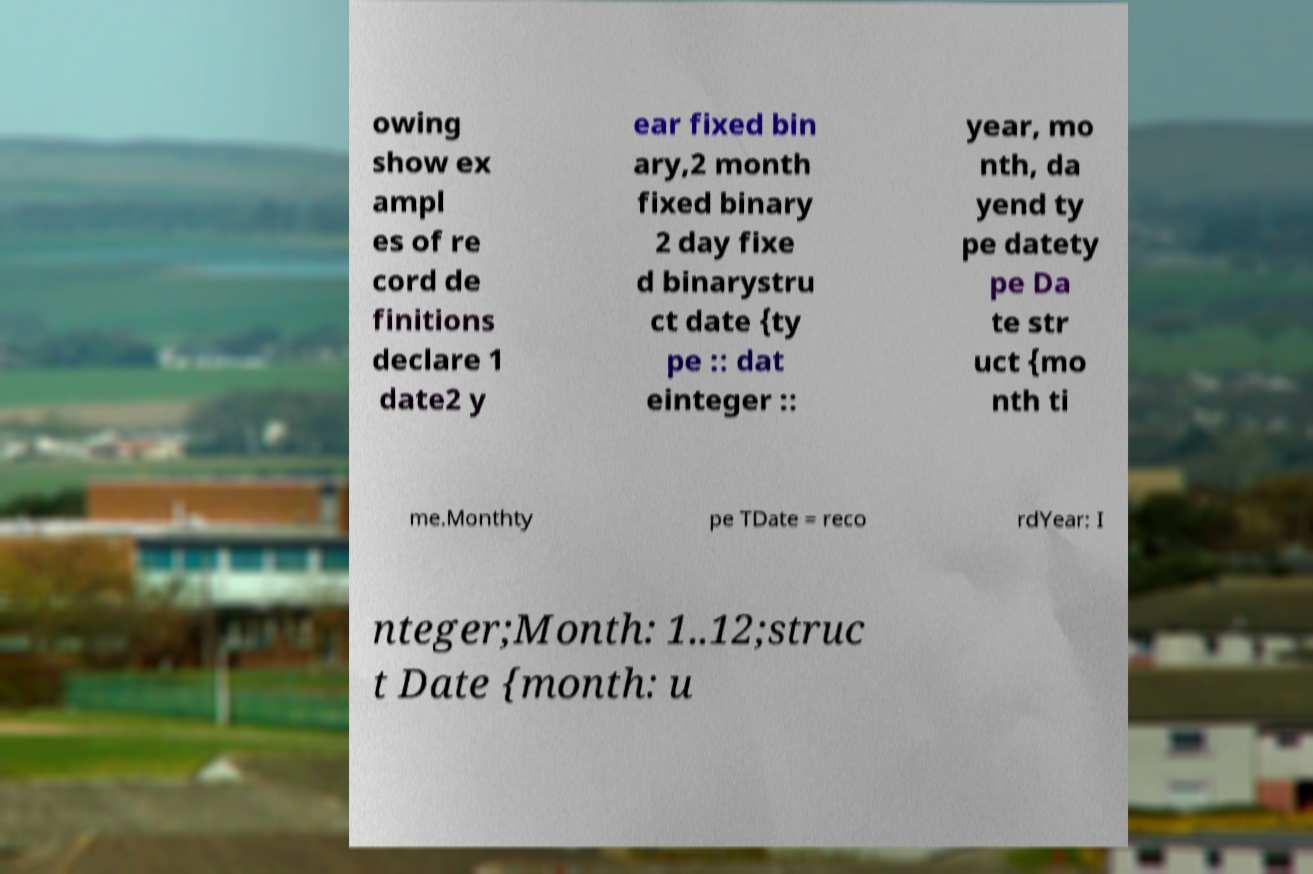Can you read and provide the text displayed in the image?This photo seems to have some interesting text. Can you extract and type it out for me? owing show ex ampl es of re cord de finitions declare 1 date2 y ear fixed bin ary,2 month fixed binary 2 day fixe d binarystru ct date {ty pe :: dat einteger :: year, mo nth, da yend ty pe datety pe Da te str uct {mo nth ti me.Monthty pe TDate = reco rdYear: I nteger;Month: 1..12;struc t Date {month: u 